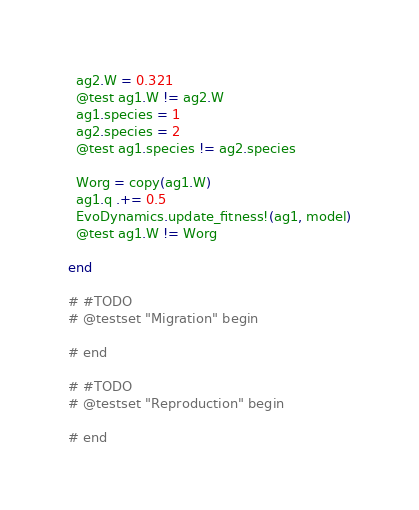<code> <loc_0><loc_0><loc_500><loc_500><_Julia_>  ag2.W = 0.321
  @test ag1.W != ag2.W
  ag1.species = 1
  ag2.species = 2
  @test ag1.species != ag2.species

  Worg = copy(ag1.W)
  ag1.q .+= 0.5
  EvoDynamics.update_fitness!(ag1, model)
  @test ag1.W != Worg

end

# #TODO
# @testset "Migration" begin

# end

# #TODO
# @testset "Reproduction" begin

# end
</code> 